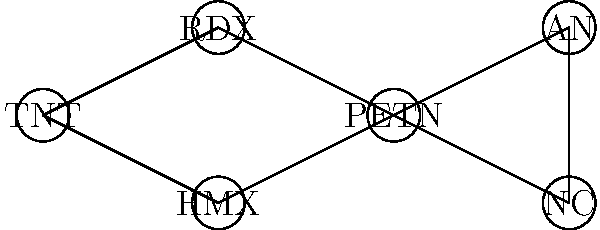In the network diagram of explosive compounds, which compound has the highest degree centrality (i.e., the most connections to other compounds)? To determine the compound with the highest degree centrality, we need to count the number of connections (edges) for each node in the graph:

1. TNT: 2 connections (to RDX and HMX)
2. RDX: 2 connections (to TNT and PETN)
3. HMX: 2 connections (to TNT and PETN)
4. PETN: 4 connections (to RDX, HMX, AN, and NC)
5. AN: 2 connections (to PETN and NC)
6. NC: 2 connections (to PETN and AN)

By counting the connections, we can see that PETN has the highest number of connections with 4, while all other compounds have 2 connections each.

Therefore, PETN has the highest degree centrality in this network of explosive compounds.
Answer: PETN 